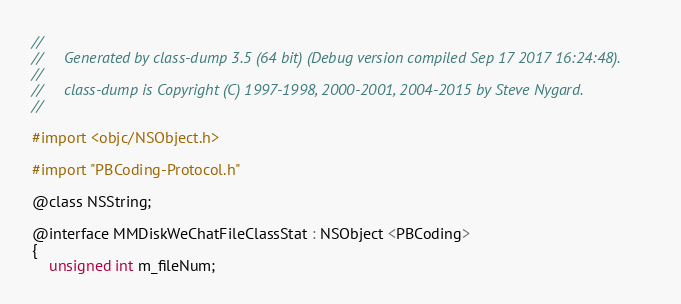Convert code to text. <code><loc_0><loc_0><loc_500><loc_500><_C_>//
//     Generated by class-dump 3.5 (64 bit) (Debug version compiled Sep 17 2017 16:24:48).
//
//     class-dump is Copyright (C) 1997-1998, 2000-2001, 2004-2015 by Steve Nygard.
//

#import <objc/NSObject.h>

#import "PBCoding-Protocol.h"

@class NSString;

@interface MMDiskWeChatFileClassStat : NSObject <PBCoding>
{
    unsigned int m_fileNum;</code> 